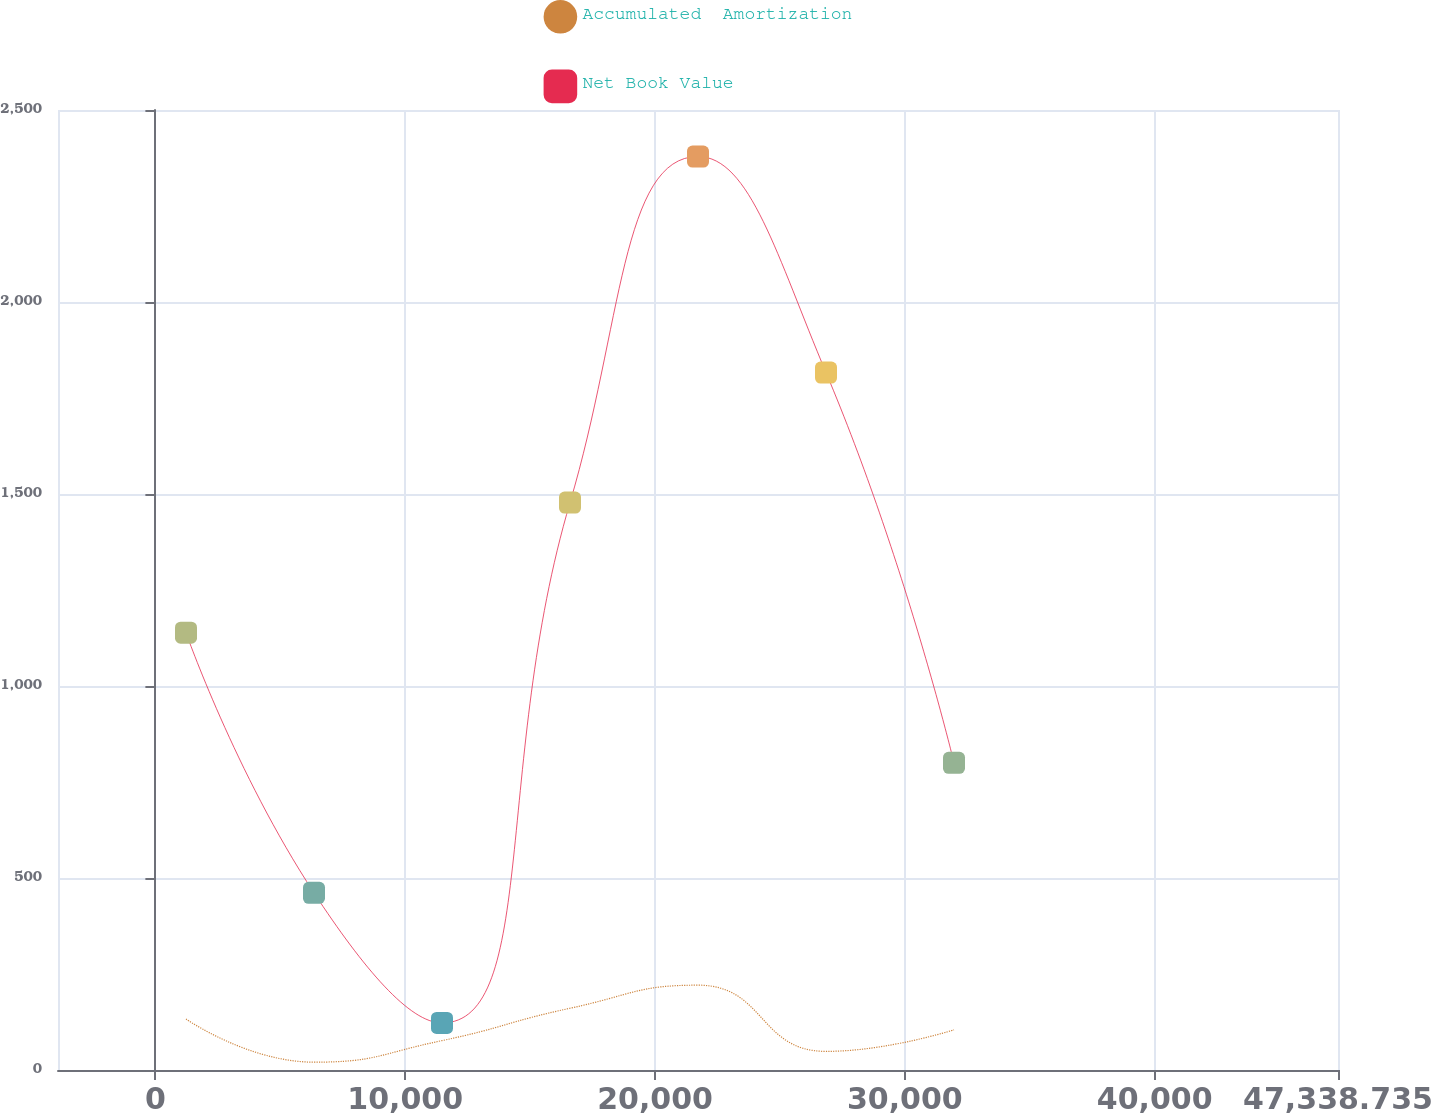Convert chart. <chart><loc_0><loc_0><loc_500><loc_500><line_chart><ecel><fcel>Accumulated  Amortization<fcel>Net Book Value<nl><fcel>1225.21<fcel>132.71<fcel>1138.81<nl><fcel>6348.94<fcel>20.39<fcel>461.31<nl><fcel>11472.7<fcel>76.55<fcel>122.56<nl><fcel>16596.4<fcel>160.79<fcel>1477.56<nl><fcel>21720.1<fcel>220.91<fcel>2378.82<nl><fcel>26843.8<fcel>48.47<fcel>1816.31<nl><fcel>31967.6<fcel>104.63<fcel>800.06<nl><fcel>52462.5<fcel>301.18<fcel>3510.05<nl></chart> 